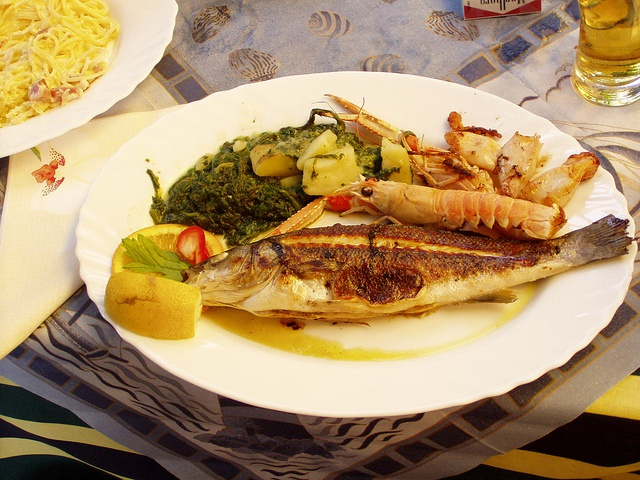Describe the objects in this image and their specific colors. I can see dining table in gold, black, darkgray, tan, and gray tones and cup in gold, olive, orange, and tan tones in this image. 